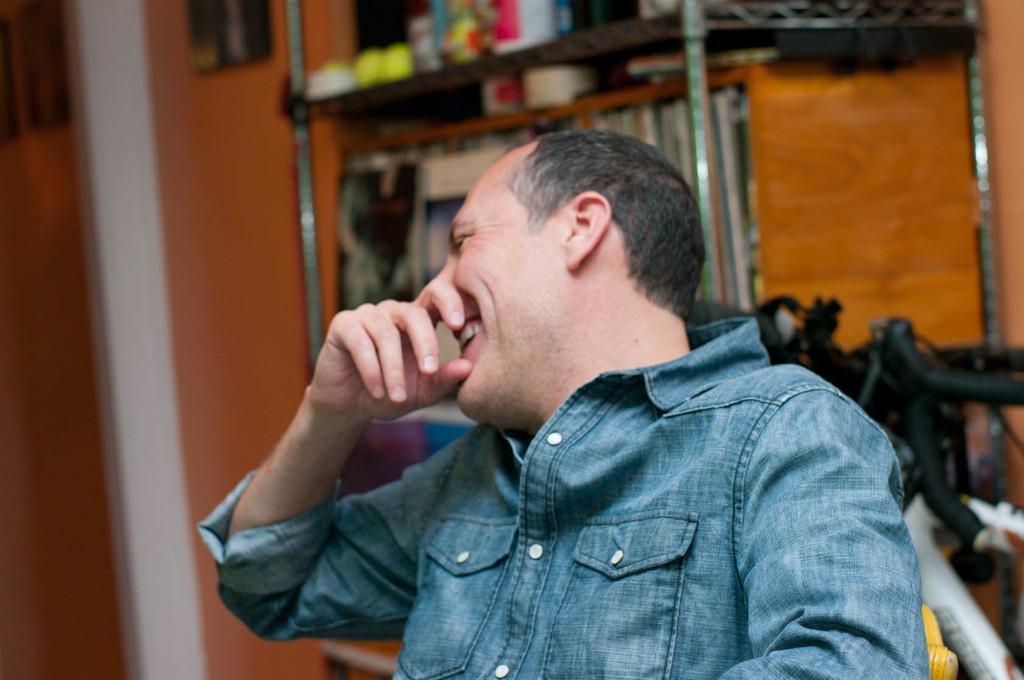Could you give a brief overview of what you see in this image? In this image in the front there is a person sitting and smiling. In the background there is a shelf and in the shelf there are objects and there is a wall and there are objects which are black in colour and white in colour. 